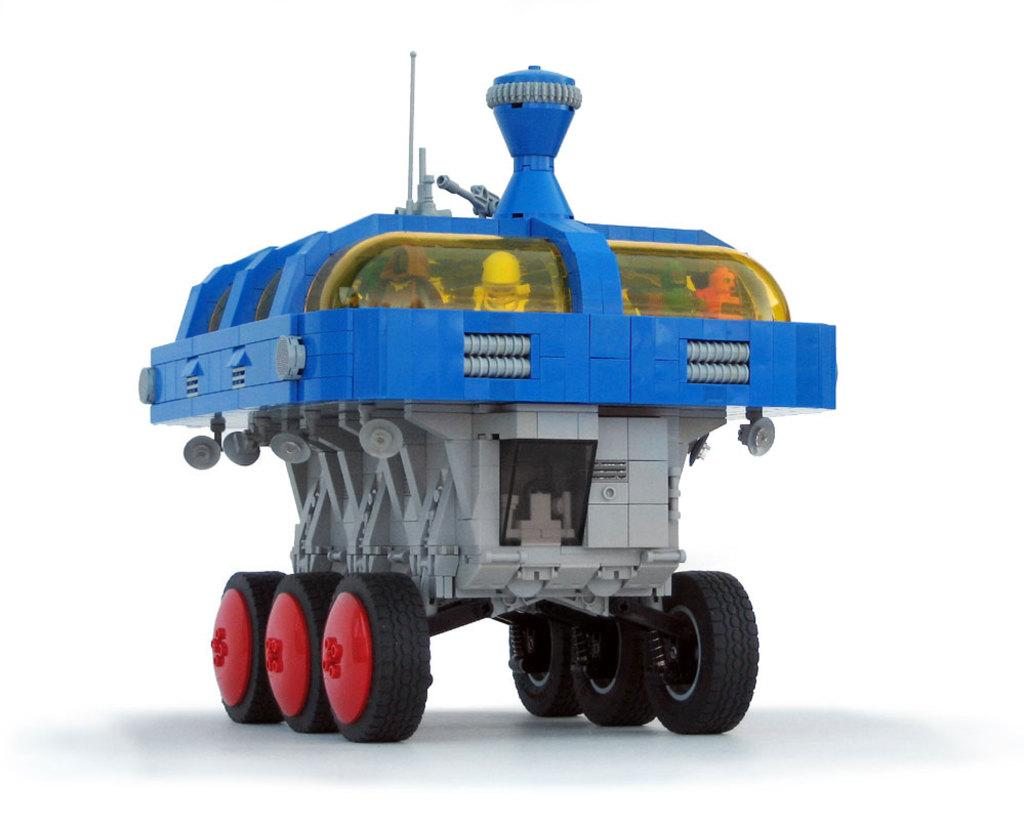What type of toy is present in the image? There is a toy motor vehicle in the image. Can you describe the toy in more detail? The toy motor vehicle is a small replica of a real car or truck. What might a child do with this toy? A child might play with the toy motor vehicle, pretending to drive it or imagining different scenarios. How many thumbs does the toy motor vehicle have in the image? The toy motor vehicle does not have thumbs, as it is an inanimate object and not a living being. 